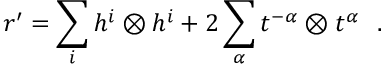<formula> <loc_0><loc_0><loc_500><loc_500>r ^ { \prime } = \sum _ { i } h ^ { i } \otimes h ^ { i } + 2 \sum _ { \alpha } t ^ { - \alpha } \otimes t ^ { \alpha } \ \ .</formula> 